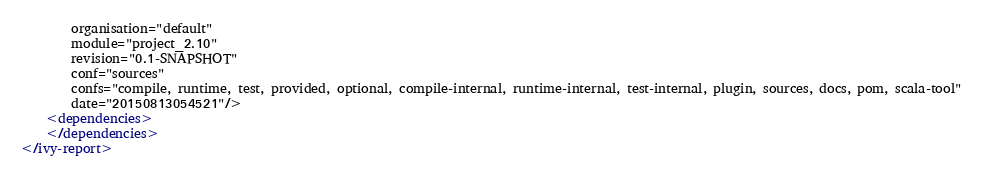<code> <loc_0><loc_0><loc_500><loc_500><_XML_>		organisation="default"
		module="project_2.10"
		revision="0.1-SNAPSHOT"
		conf="sources"
		confs="compile, runtime, test, provided, optional, compile-internal, runtime-internal, test-internal, plugin, sources, docs, pom, scala-tool"
		date="20150813054521"/>
	<dependencies>
	</dependencies>
</ivy-report>
</code> 